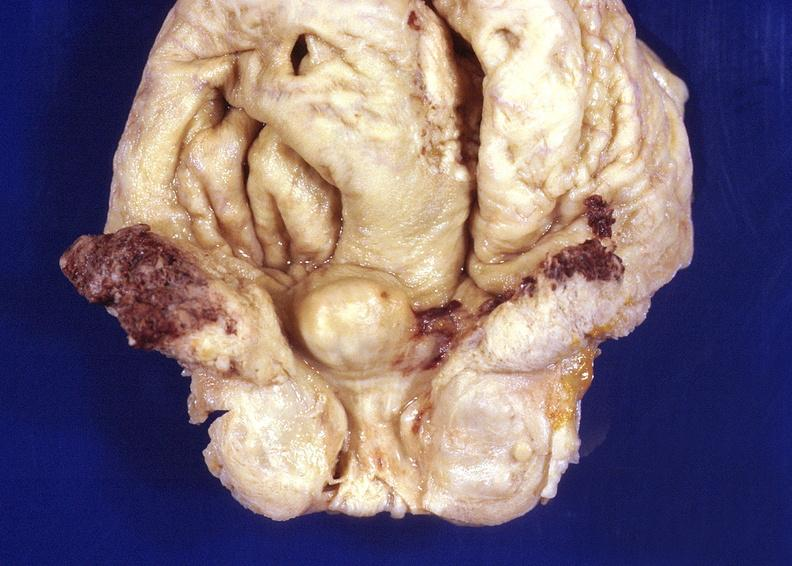what does this image show?
Answer the question using a single word or phrase. Prostatic hyperplasia 